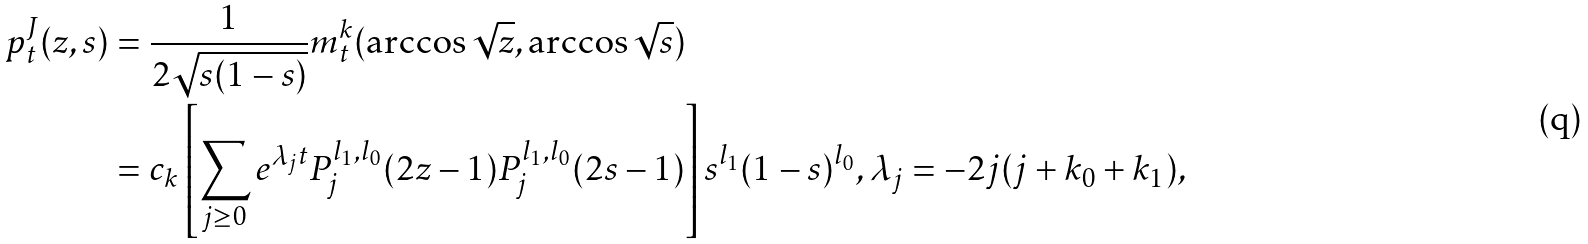<formula> <loc_0><loc_0><loc_500><loc_500>p _ { t } ^ { J } ( z , s ) & = \frac { 1 } { 2 \sqrt { s ( 1 - s ) } } m _ { t } ^ { k } ( \arccos \sqrt { z } , \arccos \sqrt { s } ) \\ & = c _ { k } \left [ \sum _ { j \geq 0 } e ^ { \lambda _ { j } t } P _ { j } ^ { l _ { 1 } , l _ { 0 } } ( 2 z - 1 ) P _ { j } ^ { l _ { 1 } , l _ { 0 } } ( 2 s - 1 ) \right ] s ^ { l _ { 1 } } ( 1 - s ) ^ { l _ { 0 } } , \lambda _ { j } = - 2 j ( j + k _ { 0 } + k _ { 1 } ) ,</formula> 